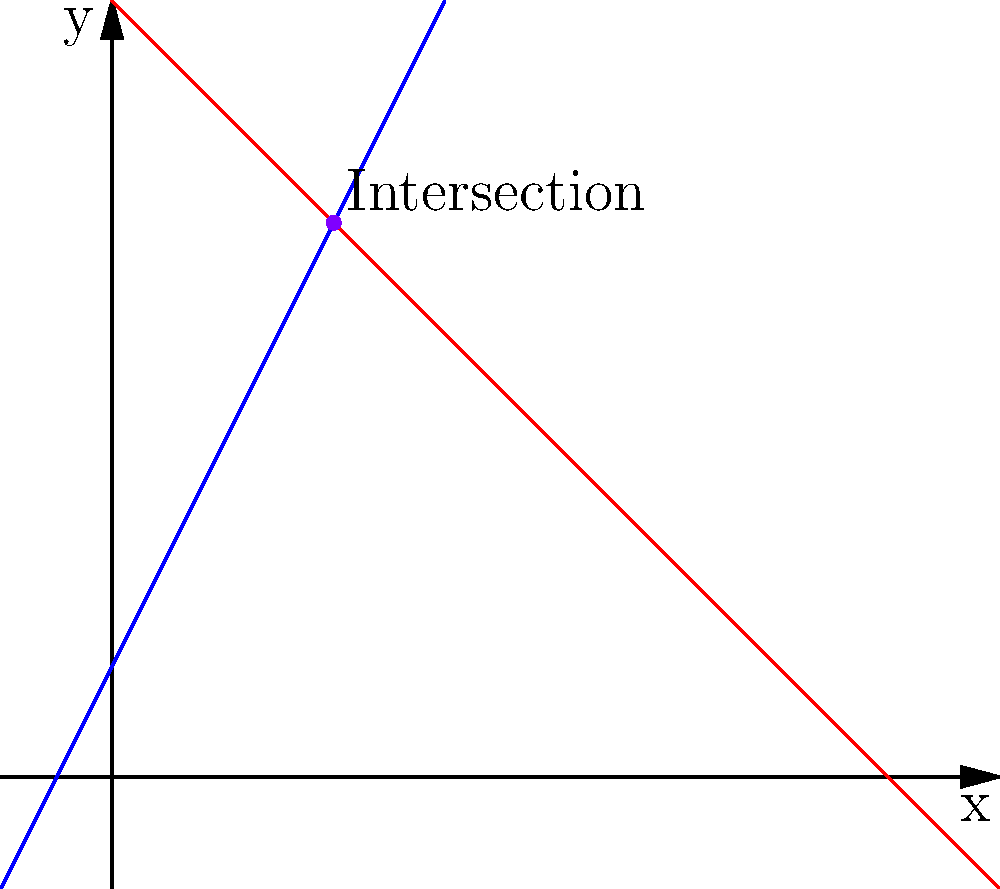A flight from Toronto to Dubai follows the path represented by the blue line $y = 2x + 1$, while a flight from Dubai to Vancouver follows the path represented by the red line $y = -x + 7$. At what point do these flight paths intersect? To find the intersection point of the two flight paths, we need to solve the system of equations:

1) $y = 2x + 1$ (Toronto to Dubai)
2) $y = -x + 7$ (Dubai to Vancouver)

At the intersection point, the y-coordinates will be equal. So we can set the right sides of these equations equal to each other:

3) $2x + 1 = -x + 7$

Now, let's solve this equation:

4) $2x + 1 = -x + 7$
5) $3x = 6$
6) $x = 2$

Now that we know the x-coordinate of the intersection point, we can substitute this back into either of the original equations to find the y-coordinate. Let's use the first equation:

7) $y = 2(2) + 1 = 4 + 1 = 5$

Therefore, the flight paths intersect at the point $(2, 5)$.
Answer: $(2, 5)$ 